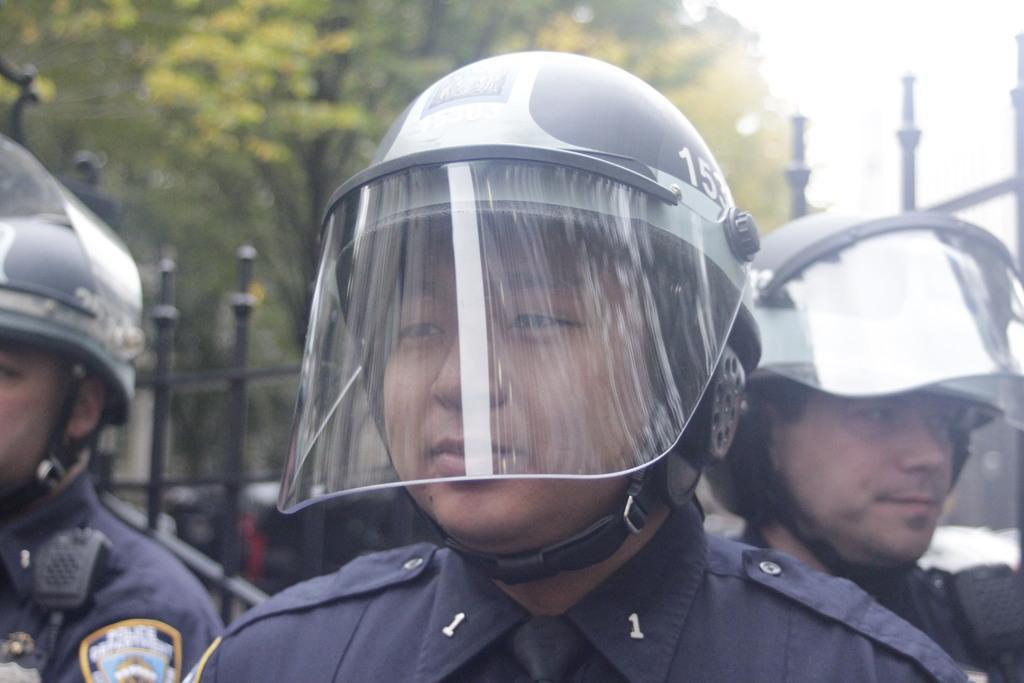In one or two sentences, can you explain what this image depicts? In this image we can see three persons and they wore helmets. In the background we can see fence, trees, and sky. 